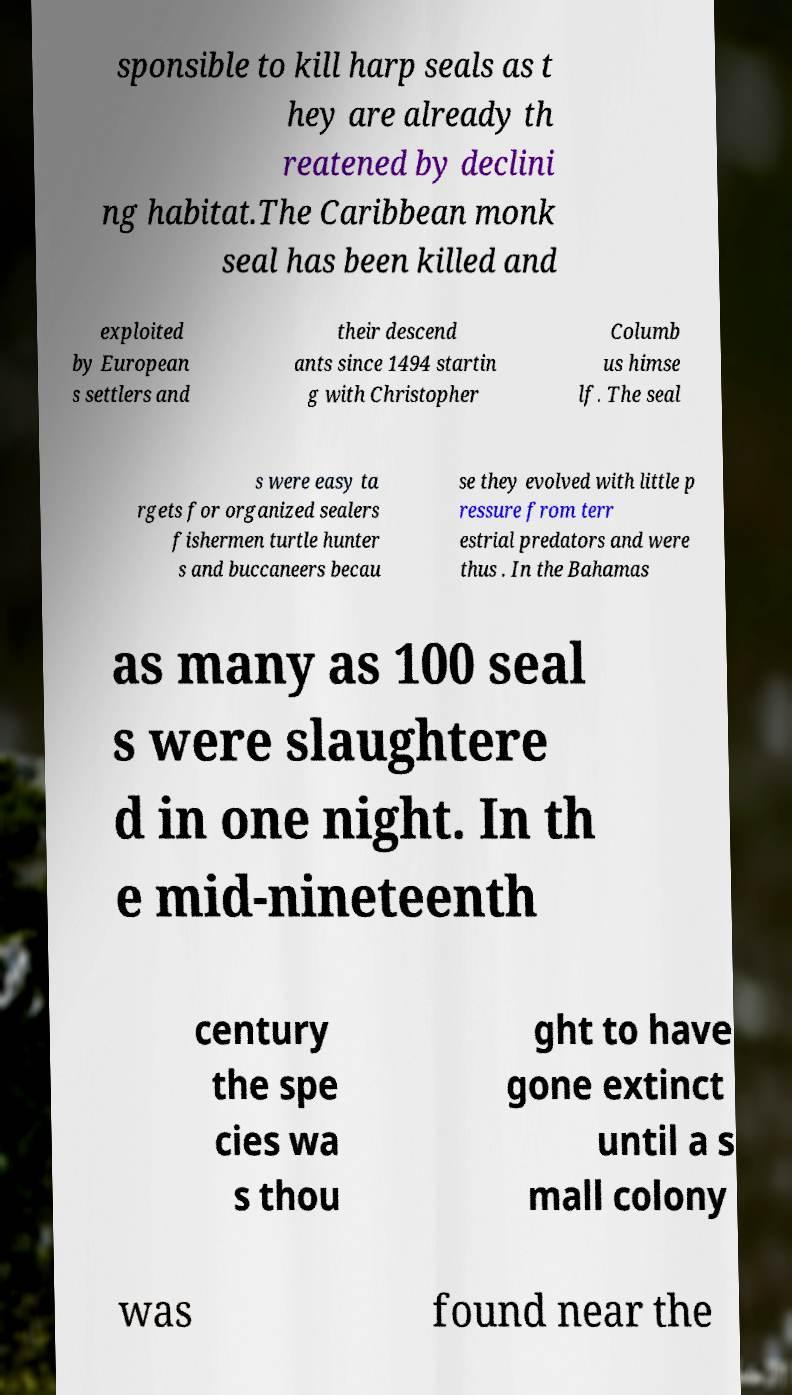For documentation purposes, I need the text within this image transcribed. Could you provide that? sponsible to kill harp seals as t hey are already th reatened by declini ng habitat.The Caribbean monk seal has been killed and exploited by European s settlers and their descend ants since 1494 startin g with Christopher Columb us himse lf. The seal s were easy ta rgets for organized sealers fishermen turtle hunter s and buccaneers becau se they evolved with little p ressure from terr estrial predators and were thus . In the Bahamas as many as 100 seal s were slaughtere d in one night. In th e mid-nineteenth century the spe cies wa s thou ght to have gone extinct until a s mall colony was found near the 